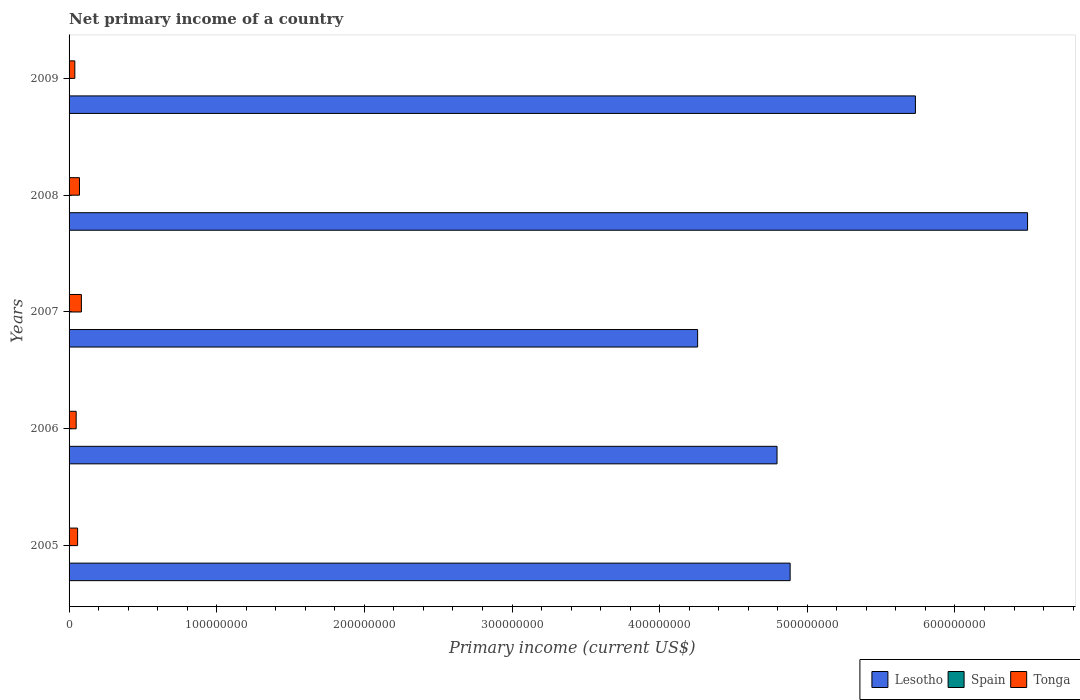How many different coloured bars are there?
Your response must be concise. 2. Are the number of bars on each tick of the Y-axis equal?
Your answer should be compact. Yes. Across all years, what is the maximum primary income in Tonga?
Your answer should be compact. 8.35e+06. Across all years, what is the minimum primary income in Lesotho?
Your response must be concise. 4.26e+08. In which year was the primary income in Tonga maximum?
Provide a short and direct response. 2007. What is the total primary income in Lesotho in the graph?
Provide a succinct answer. 2.62e+09. What is the difference between the primary income in Lesotho in 2006 and that in 2007?
Give a very brief answer. 5.38e+07. What is the difference between the primary income in Spain in 2009 and the primary income in Tonga in 2007?
Provide a succinct answer. -8.35e+06. What is the average primary income in Tonga per year?
Provide a short and direct response. 5.98e+06. In the year 2008, what is the difference between the primary income in Lesotho and primary income in Tonga?
Ensure brevity in your answer.  6.42e+08. In how many years, is the primary income in Spain greater than 500000000 US$?
Your response must be concise. 0. What is the ratio of the primary income in Lesotho in 2005 to that in 2009?
Provide a succinct answer. 0.85. Is the difference between the primary income in Lesotho in 2005 and 2006 greater than the difference between the primary income in Tonga in 2005 and 2006?
Offer a terse response. Yes. What is the difference between the highest and the second highest primary income in Lesotho?
Give a very brief answer. 7.59e+07. What is the difference between the highest and the lowest primary income in Tonga?
Offer a very short reply. 4.45e+06. Is the sum of the primary income in Lesotho in 2007 and 2009 greater than the maximum primary income in Spain across all years?
Provide a succinct answer. Yes. Is it the case that in every year, the sum of the primary income in Tonga and primary income in Lesotho is greater than the primary income in Spain?
Your answer should be compact. Yes. How many bars are there?
Your answer should be very brief. 10. How many years are there in the graph?
Your answer should be compact. 5. Are the values on the major ticks of X-axis written in scientific E-notation?
Give a very brief answer. No. How many legend labels are there?
Offer a very short reply. 3. How are the legend labels stacked?
Your answer should be very brief. Horizontal. What is the title of the graph?
Offer a terse response. Net primary income of a country. What is the label or title of the X-axis?
Give a very brief answer. Primary income (current US$). What is the Primary income (current US$) in Lesotho in 2005?
Your response must be concise. 4.88e+08. What is the Primary income (current US$) of Spain in 2005?
Ensure brevity in your answer.  0. What is the Primary income (current US$) of Tonga in 2005?
Give a very brief answer. 5.79e+06. What is the Primary income (current US$) in Lesotho in 2006?
Your answer should be compact. 4.79e+08. What is the Primary income (current US$) of Tonga in 2006?
Offer a terse response. 4.81e+06. What is the Primary income (current US$) of Lesotho in 2007?
Ensure brevity in your answer.  4.26e+08. What is the Primary income (current US$) in Spain in 2007?
Provide a succinct answer. 0. What is the Primary income (current US$) in Tonga in 2007?
Your response must be concise. 8.35e+06. What is the Primary income (current US$) of Lesotho in 2008?
Your answer should be compact. 6.49e+08. What is the Primary income (current US$) of Tonga in 2008?
Provide a short and direct response. 7.04e+06. What is the Primary income (current US$) in Lesotho in 2009?
Make the answer very short. 5.73e+08. What is the Primary income (current US$) in Spain in 2009?
Your answer should be compact. 0. What is the Primary income (current US$) in Tonga in 2009?
Provide a short and direct response. 3.90e+06. Across all years, what is the maximum Primary income (current US$) in Lesotho?
Your answer should be compact. 6.49e+08. Across all years, what is the maximum Primary income (current US$) in Tonga?
Your response must be concise. 8.35e+06. Across all years, what is the minimum Primary income (current US$) of Lesotho?
Keep it short and to the point. 4.26e+08. Across all years, what is the minimum Primary income (current US$) in Tonga?
Your answer should be very brief. 3.90e+06. What is the total Primary income (current US$) in Lesotho in the graph?
Offer a terse response. 2.62e+09. What is the total Primary income (current US$) in Spain in the graph?
Offer a terse response. 0. What is the total Primary income (current US$) in Tonga in the graph?
Make the answer very short. 2.99e+07. What is the difference between the Primary income (current US$) of Lesotho in 2005 and that in 2006?
Keep it short and to the point. 8.88e+06. What is the difference between the Primary income (current US$) in Tonga in 2005 and that in 2006?
Give a very brief answer. 9.78e+05. What is the difference between the Primary income (current US$) of Lesotho in 2005 and that in 2007?
Your response must be concise. 6.27e+07. What is the difference between the Primary income (current US$) in Tonga in 2005 and that in 2007?
Ensure brevity in your answer.  -2.56e+06. What is the difference between the Primary income (current US$) of Lesotho in 2005 and that in 2008?
Offer a very short reply. -1.61e+08. What is the difference between the Primary income (current US$) of Tonga in 2005 and that in 2008?
Your answer should be very brief. -1.26e+06. What is the difference between the Primary income (current US$) in Lesotho in 2005 and that in 2009?
Give a very brief answer. -8.49e+07. What is the difference between the Primary income (current US$) of Tonga in 2005 and that in 2009?
Give a very brief answer. 1.89e+06. What is the difference between the Primary income (current US$) of Lesotho in 2006 and that in 2007?
Provide a short and direct response. 5.38e+07. What is the difference between the Primary income (current US$) in Tonga in 2006 and that in 2007?
Ensure brevity in your answer.  -3.54e+06. What is the difference between the Primary income (current US$) in Lesotho in 2006 and that in 2008?
Give a very brief answer. -1.70e+08. What is the difference between the Primary income (current US$) in Tonga in 2006 and that in 2008?
Provide a succinct answer. -2.24e+06. What is the difference between the Primary income (current US$) in Lesotho in 2006 and that in 2009?
Your answer should be very brief. -9.37e+07. What is the difference between the Primary income (current US$) of Tonga in 2006 and that in 2009?
Provide a succinct answer. 9.08e+05. What is the difference between the Primary income (current US$) of Lesotho in 2007 and that in 2008?
Provide a short and direct response. -2.23e+08. What is the difference between the Primary income (current US$) in Tonga in 2007 and that in 2008?
Provide a short and direct response. 1.30e+06. What is the difference between the Primary income (current US$) in Lesotho in 2007 and that in 2009?
Offer a very short reply. -1.48e+08. What is the difference between the Primary income (current US$) of Tonga in 2007 and that in 2009?
Provide a short and direct response. 4.45e+06. What is the difference between the Primary income (current US$) in Lesotho in 2008 and that in 2009?
Make the answer very short. 7.59e+07. What is the difference between the Primary income (current US$) of Tonga in 2008 and that in 2009?
Keep it short and to the point. 3.14e+06. What is the difference between the Primary income (current US$) in Lesotho in 2005 and the Primary income (current US$) in Tonga in 2006?
Your answer should be compact. 4.84e+08. What is the difference between the Primary income (current US$) of Lesotho in 2005 and the Primary income (current US$) of Tonga in 2007?
Your answer should be compact. 4.80e+08. What is the difference between the Primary income (current US$) in Lesotho in 2005 and the Primary income (current US$) in Tonga in 2008?
Make the answer very short. 4.81e+08. What is the difference between the Primary income (current US$) in Lesotho in 2005 and the Primary income (current US$) in Tonga in 2009?
Give a very brief answer. 4.84e+08. What is the difference between the Primary income (current US$) in Lesotho in 2006 and the Primary income (current US$) in Tonga in 2007?
Your response must be concise. 4.71e+08. What is the difference between the Primary income (current US$) of Lesotho in 2006 and the Primary income (current US$) of Tonga in 2008?
Your answer should be very brief. 4.72e+08. What is the difference between the Primary income (current US$) of Lesotho in 2006 and the Primary income (current US$) of Tonga in 2009?
Provide a succinct answer. 4.76e+08. What is the difference between the Primary income (current US$) in Lesotho in 2007 and the Primary income (current US$) in Tonga in 2008?
Your answer should be very brief. 4.19e+08. What is the difference between the Primary income (current US$) in Lesotho in 2007 and the Primary income (current US$) in Tonga in 2009?
Your response must be concise. 4.22e+08. What is the difference between the Primary income (current US$) of Lesotho in 2008 and the Primary income (current US$) of Tonga in 2009?
Offer a very short reply. 6.45e+08. What is the average Primary income (current US$) in Lesotho per year?
Offer a very short reply. 5.23e+08. What is the average Primary income (current US$) in Tonga per year?
Ensure brevity in your answer.  5.98e+06. In the year 2005, what is the difference between the Primary income (current US$) in Lesotho and Primary income (current US$) in Tonga?
Your answer should be very brief. 4.83e+08. In the year 2006, what is the difference between the Primary income (current US$) of Lesotho and Primary income (current US$) of Tonga?
Your response must be concise. 4.75e+08. In the year 2007, what is the difference between the Primary income (current US$) in Lesotho and Primary income (current US$) in Tonga?
Provide a succinct answer. 4.17e+08. In the year 2008, what is the difference between the Primary income (current US$) in Lesotho and Primary income (current US$) in Tonga?
Keep it short and to the point. 6.42e+08. In the year 2009, what is the difference between the Primary income (current US$) of Lesotho and Primary income (current US$) of Tonga?
Give a very brief answer. 5.69e+08. What is the ratio of the Primary income (current US$) in Lesotho in 2005 to that in 2006?
Ensure brevity in your answer.  1.02. What is the ratio of the Primary income (current US$) in Tonga in 2005 to that in 2006?
Keep it short and to the point. 1.2. What is the ratio of the Primary income (current US$) in Lesotho in 2005 to that in 2007?
Keep it short and to the point. 1.15. What is the ratio of the Primary income (current US$) of Tonga in 2005 to that in 2007?
Your answer should be compact. 0.69. What is the ratio of the Primary income (current US$) of Lesotho in 2005 to that in 2008?
Make the answer very short. 0.75. What is the ratio of the Primary income (current US$) of Tonga in 2005 to that in 2008?
Your answer should be very brief. 0.82. What is the ratio of the Primary income (current US$) of Lesotho in 2005 to that in 2009?
Make the answer very short. 0.85. What is the ratio of the Primary income (current US$) of Tonga in 2005 to that in 2009?
Provide a succinct answer. 1.48. What is the ratio of the Primary income (current US$) in Lesotho in 2006 to that in 2007?
Give a very brief answer. 1.13. What is the ratio of the Primary income (current US$) of Tonga in 2006 to that in 2007?
Your answer should be compact. 0.58. What is the ratio of the Primary income (current US$) of Lesotho in 2006 to that in 2008?
Your response must be concise. 0.74. What is the ratio of the Primary income (current US$) of Tonga in 2006 to that in 2008?
Give a very brief answer. 0.68. What is the ratio of the Primary income (current US$) in Lesotho in 2006 to that in 2009?
Offer a very short reply. 0.84. What is the ratio of the Primary income (current US$) of Tonga in 2006 to that in 2009?
Make the answer very short. 1.23. What is the ratio of the Primary income (current US$) in Lesotho in 2007 to that in 2008?
Keep it short and to the point. 0.66. What is the ratio of the Primary income (current US$) of Tonga in 2007 to that in 2008?
Offer a very short reply. 1.18. What is the ratio of the Primary income (current US$) of Lesotho in 2007 to that in 2009?
Keep it short and to the point. 0.74. What is the ratio of the Primary income (current US$) in Tonga in 2007 to that in 2009?
Make the answer very short. 2.14. What is the ratio of the Primary income (current US$) in Lesotho in 2008 to that in 2009?
Your answer should be very brief. 1.13. What is the ratio of the Primary income (current US$) of Tonga in 2008 to that in 2009?
Offer a terse response. 1.81. What is the difference between the highest and the second highest Primary income (current US$) in Lesotho?
Offer a terse response. 7.59e+07. What is the difference between the highest and the second highest Primary income (current US$) of Tonga?
Your answer should be very brief. 1.30e+06. What is the difference between the highest and the lowest Primary income (current US$) of Lesotho?
Offer a very short reply. 2.23e+08. What is the difference between the highest and the lowest Primary income (current US$) in Tonga?
Provide a succinct answer. 4.45e+06. 